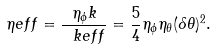Convert formula to latex. <formula><loc_0><loc_0><loc_500><loc_500>\eta e f f = \frac { \eta _ { \phi } k } { \ k e f f } = \frac { 5 } { 4 } \eta _ { \phi } \eta _ { \theta } ( \delta \theta ) ^ { 2 } .</formula> 